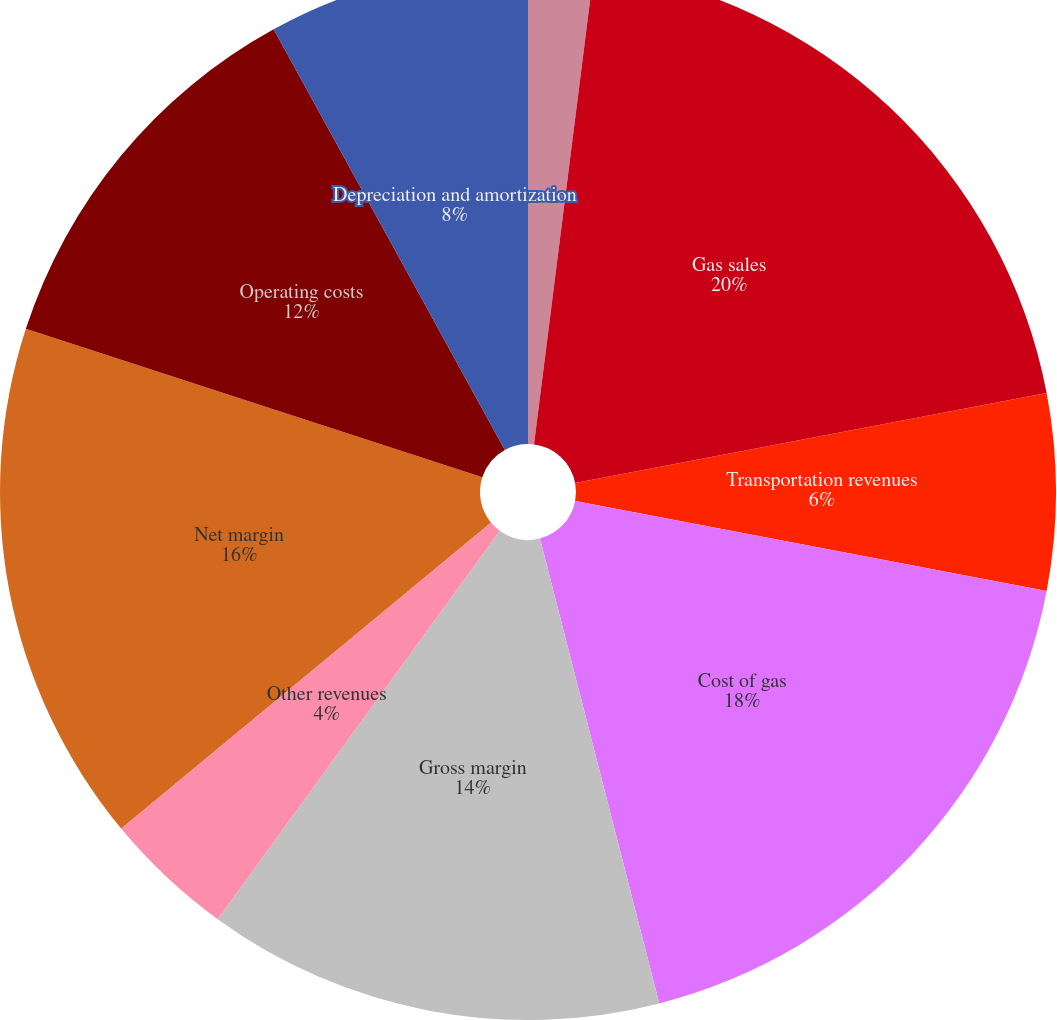Convert chart. <chart><loc_0><loc_0><loc_500><loc_500><pie_chart><fcel>Financial Results<fcel>Gas sales<fcel>Transportation revenues<fcel>Cost of gas<fcel>Gross margin<fcel>Other revenues<fcel>Net margin<fcel>Operating costs<fcel>Depreciation and amortization<fcel>Gain (loss) on sale of assets<nl><fcel>2.0%<fcel>20.0%<fcel>6.0%<fcel>18.0%<fcel>14.0%<fcel>4.0%<fcel>16.0%<fcel>12.0%<fcel>8.0%<fcel>0.0%<nl></chart> 